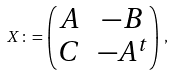<formula> <loc_0><loc_0><loc_500><loc_500>X \colon = \begin{pmatrix} A & - B \\ C & - A ^ { t } \end{pmatrix} \, ,</formula> 